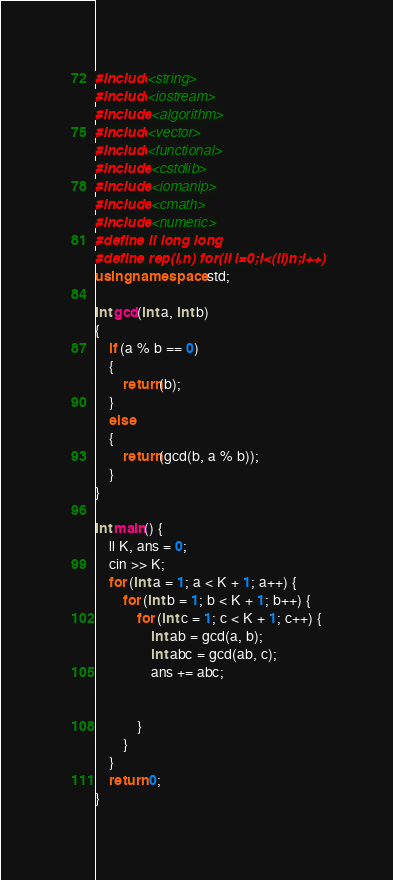<code> <loc_0><loc_0><loc_500><loc_500><_C++_>#include<string>
#include<iostream>
#include <algorithm>
#include<vector>
#include<functional>
#include <cstdlib>
#include <iomanip>
#include <cmath>
#include <numeric>
#define ll long long
#define rep(i,n) for(ll i=0;i<(ll)n;i++)
using namespace std;

int gcd(int a, int b)
{
	if (a % b == 0)
	{
		return(b);
	}
	else
	{
		return(gcd(b, a % b));
	}
}

int main() {
	ll K, ans = 0;
	cin >> K;
	for (int a = 1; a < K + 1; a++) {
		for (int b = 1; b < K + 1; b++) {
			for (int c = 1; c < K + 1; c++) {
				int ab = gcd(a, b);
				int abc = gcd(ab, c);
				ans += abc;
				
				
			}
		}
	}
	return 0;
}</code> 